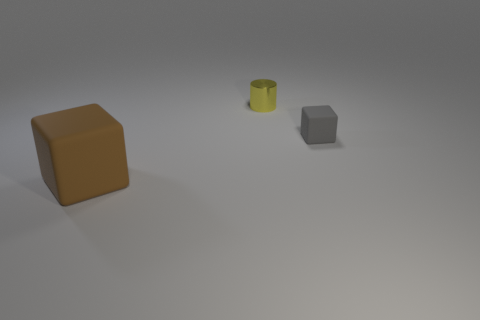Add 3 brown blocks. How many objects exist? 6 Subtract all blocks. How many objects are left? 1 Subtract 0 gray cylinders. How many objects are left? 3 Subtract all tiny things. Subtract all big matte blocks. How many objects are left? 0 Add 3 small gray matte things. How many small gray matte things are left? 4 Add 2 blue balls. How many blue balls exist? 2 